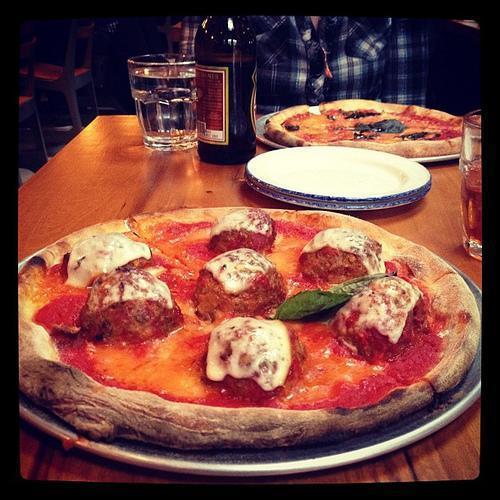How many meatballs are visible on the pizza in front?
Give a very brief answer. 7. How many bottles are in the picture?
Give a very brief answer. 1. How many glasses are visible?
Give a very brief answer. 2. How many people are visible?
Give a very brief answer. 1. How many pizzas are there?
Give a very brief answer. 2. How many glasses of water are on the table?
Give a very brief answer. 1. How many bottles are on the table?
Give a very brief answer. 1. How many bottles are there?
Give a very brief answer. 1. How many glasses are there?
Give a very brief answer. 2. How many tables are there?
Give a very brief answer. 1. 